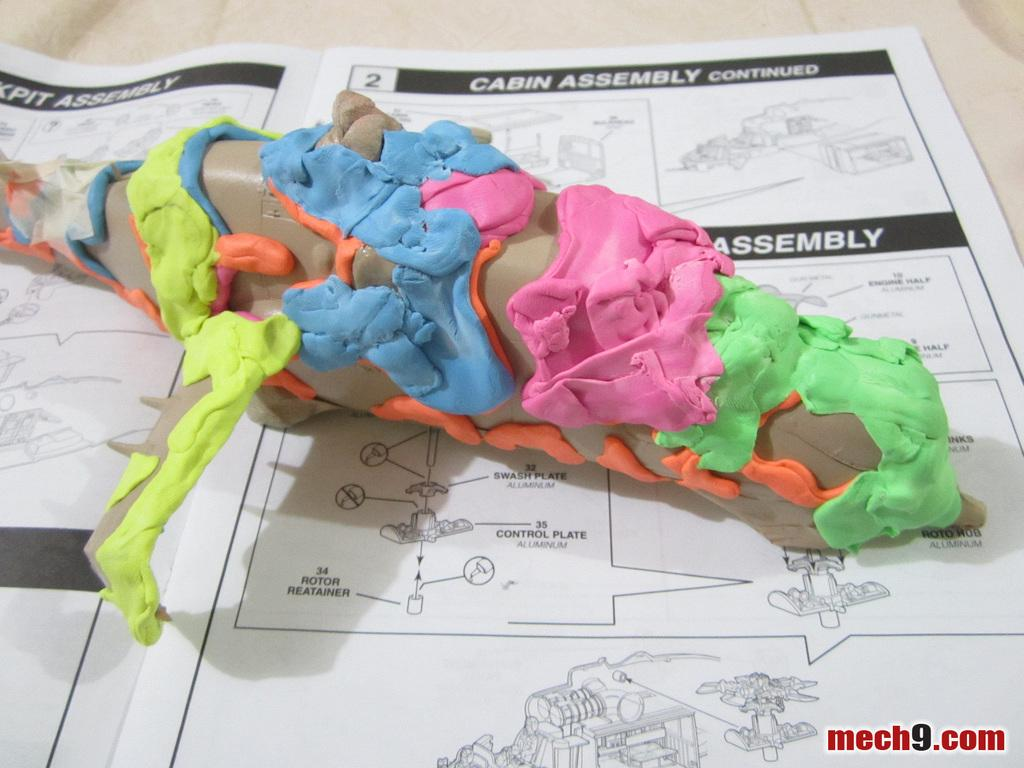What is the main object in the image? There is a toy plane in the image. Where is the toy plane located? The toy plane is on a book. What material is on the toy plane? There is clay on the toy plane. Is there any additional marking or feature in the image? Yes, there is a watermark in the right bottom corner of the image. What type of linen is used to cover the toy plane in the image? There is no linen present in the image, and the toy plane is not covered by any fabric. What rule is being enforced by the toy plane in the image? The toy plane is not enforcing any rule in the image; it is simply a toy on a book. 